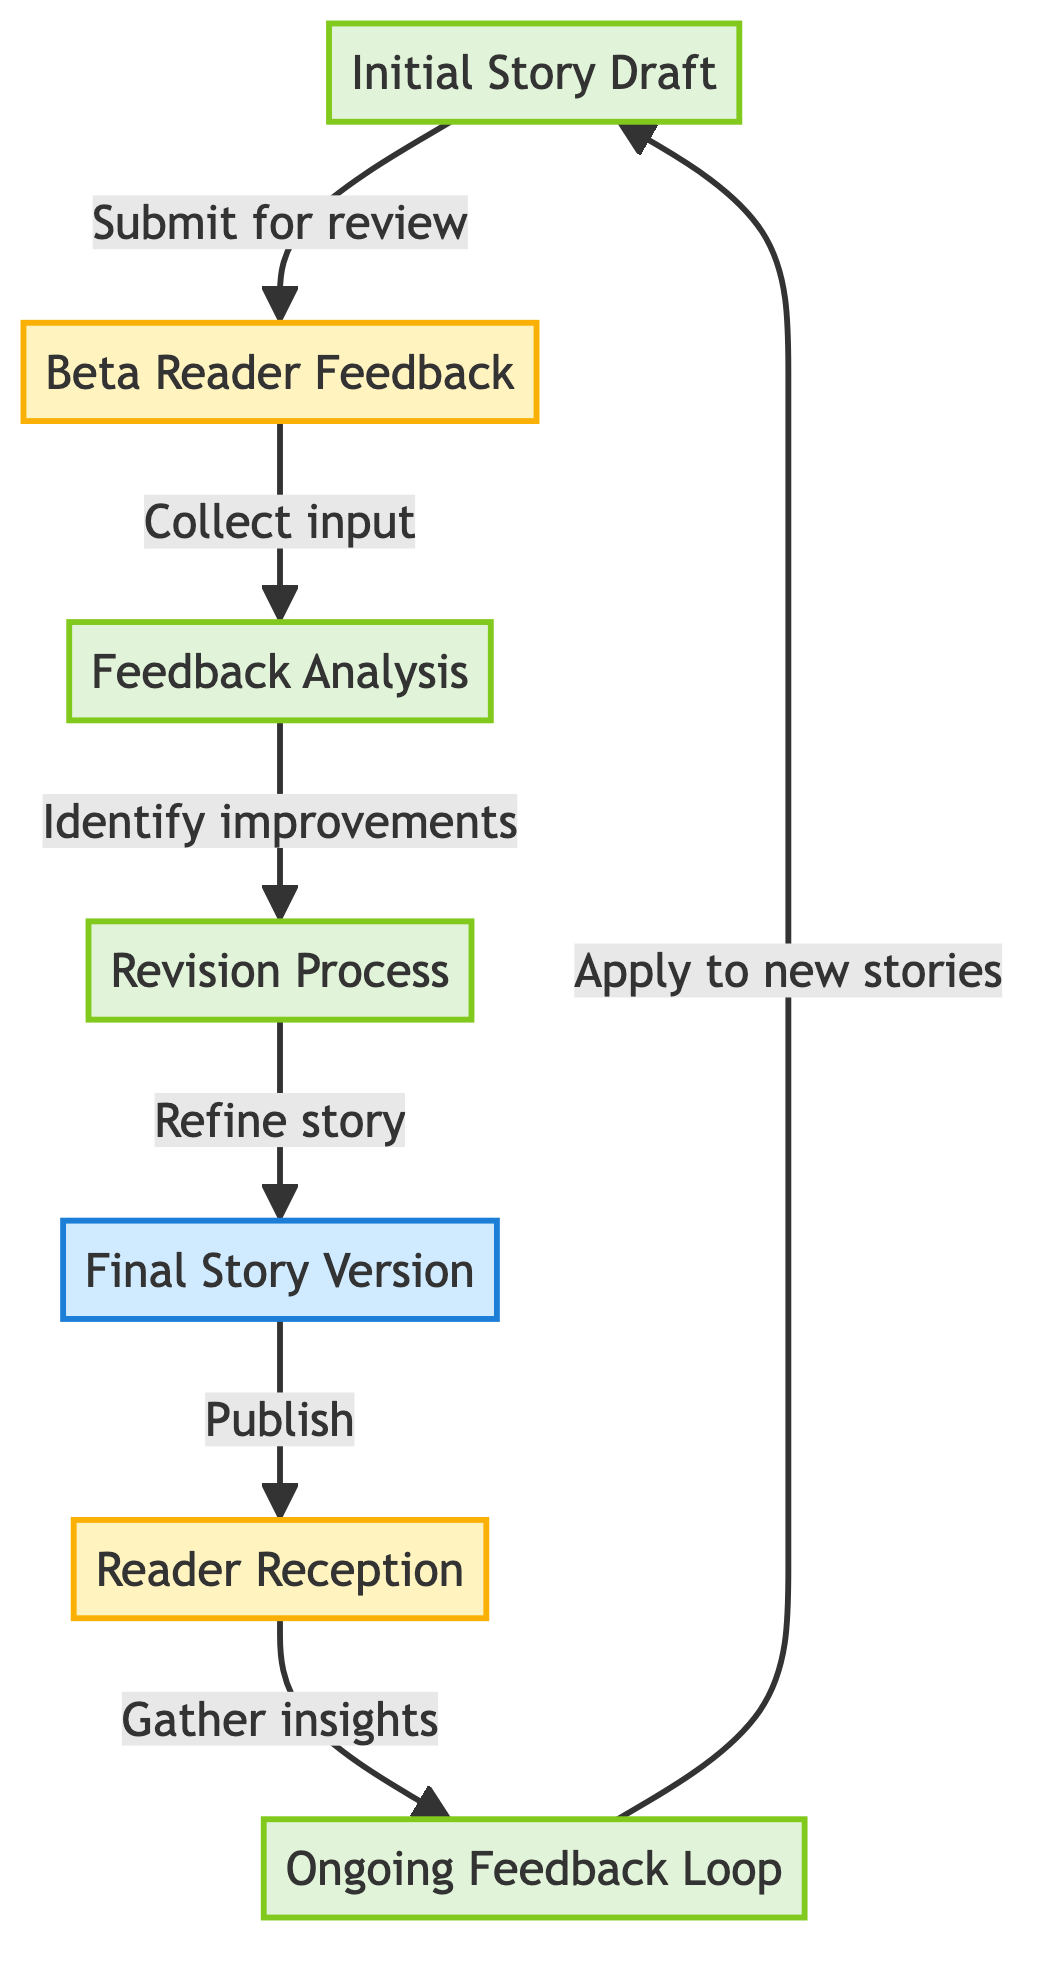What is the first step in the feedback loop? The first step in the feedback loop is "Initial Story Draft." This is the starting point of the process where the author creates the first complete version of the story.
Answer: Initial Story Draft How many nodes are there in the diagram? The diagram contains seven nodes in total, each representing different stages of the reader feedback loop.
Answer: 7 What follows "Feedback Analysis" in the process? After "Feedback Analysis," the next step is the "Revision Process." This indicates that after analyzing feedback, the author will revise the story accordingly.
Answer: Revision Process Which node is associated with submitting the story for review? "Initial Story Draft" is the node associated with submitting the story for review as it is the first complete version created by the author.
Answer: Initial Story Draft What type of input is collected from "Beta Reader Feedback"? The collected input from "Beta Reader Feedback" is feedback regarding the story's engagement and clarity, which is essential for the analysis phase.
Answer: Feedback Which stage leads directly to the audience's response post-publication? The stage that leads directly to the audience's response is "Final Story Version," as this version is published and subsequently evaluated by readers.
Answer: Final Story Version What does the "Ongoing Feedback Loop" apply to? The "Ongoing Feedback Loop" applies to gathering insights from readers to improve future stories, indicating a continuous improvement cycle in storytelling.
Answer: Future stories Which two processes are connected by the edge labeled "Refine story"? The two processes connected by the edge labeled "Refine story" are "Revision Process" and "Final Story Version," showing the flow from revisions to the polished story.
Answer: Revision Process and Final Story Version How is feedback categorized according to the diagram? Feedback is categorized during the "Feedback Analysis" phase, where feedback from beta readers is reviewed to identify common themes and suggestions.
Answer: Feedback Analysis 